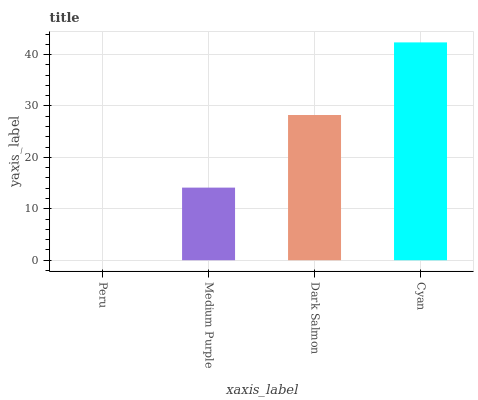Is Peru the minimum?
Answer yes or no. Yes. Is Cyan the maximum?
Answer yes or no. Yes. Is Medium Purple the minimum?
Answer yes or no. No. Is Medium Purple the maximum?
Answer yes or no. No. Is Medium Purple greater than Peru?
Answer yes or no. Yes. Is Peru less than Medium Purple?
Answer yes or no. Yes. Is Peru greater than Medium Purple?
Answer yes or no. No. Is Medium Purple less than Peru?
Answer yes or no. No. Is Dark Salmon the high median?
Answer yes or no. Yes. Is Medium Purple the low median?
Answer yes or no. Yes. Is Peru the high median?
Answer yes or no. No. Is Peru the low median?
Answer yes or no. No. 